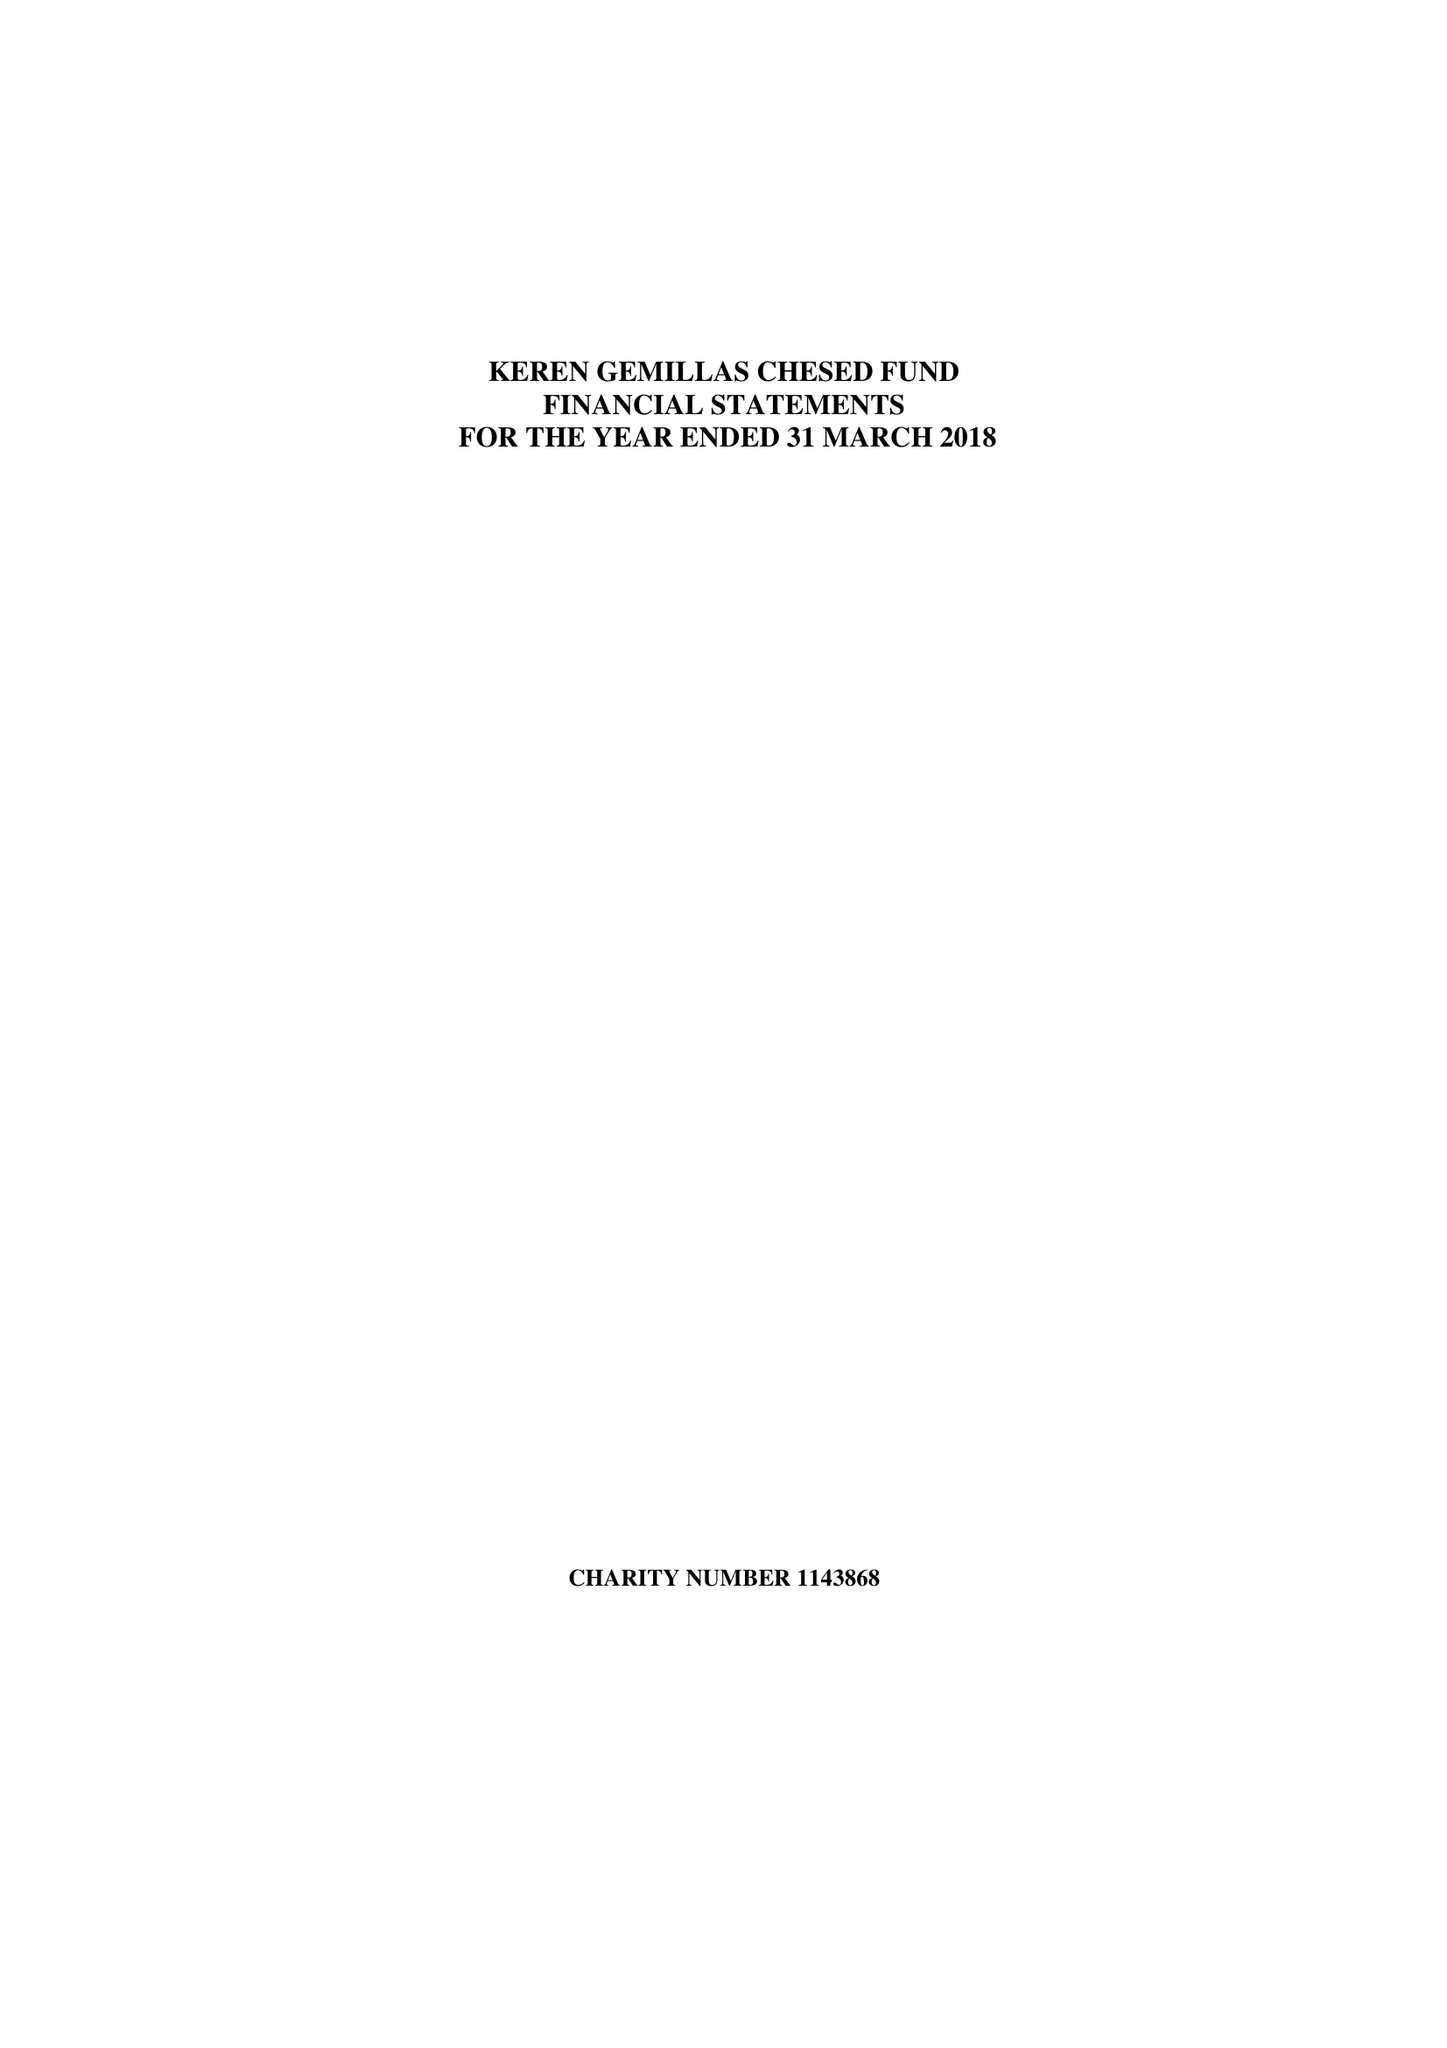What is the value for the charity_name?
Answer the question using a single word or phrase. Keren Gemillas Chesed Fund 